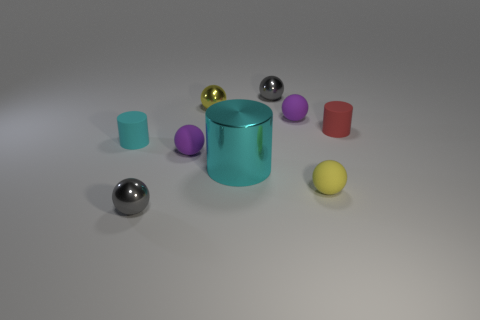What is the shape of the small yellow object that is made of the same material as the red object? sphere 